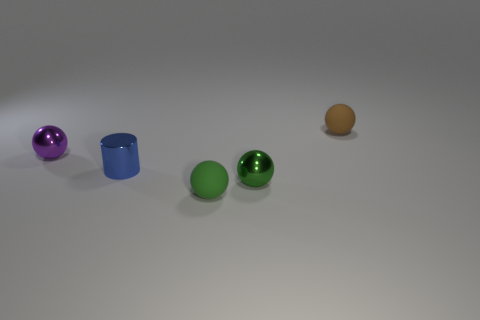Subtract all cyan cylinders. How many green spheres are left? 2 Subtract all small green rubber balls. How many balls are left? 3 Subtract all brown spheres. How many spheres are left? 3 Subtract 2 spheres. How many spheres are left? 2 Subtract all yellow balls. Subtract all purple blocks. How many balls are left? 4 Add 3 matte balls. How many objects exist? 8 Subtract 0 yellow blocks. How many objects are left? 5 Subtract all cylinders. How many objects are left? 4 Subtract all small things. Subtract all big red metallic balls. How many objects are left? 0 Add 3 cylinders. How many cylinders are left? 4 